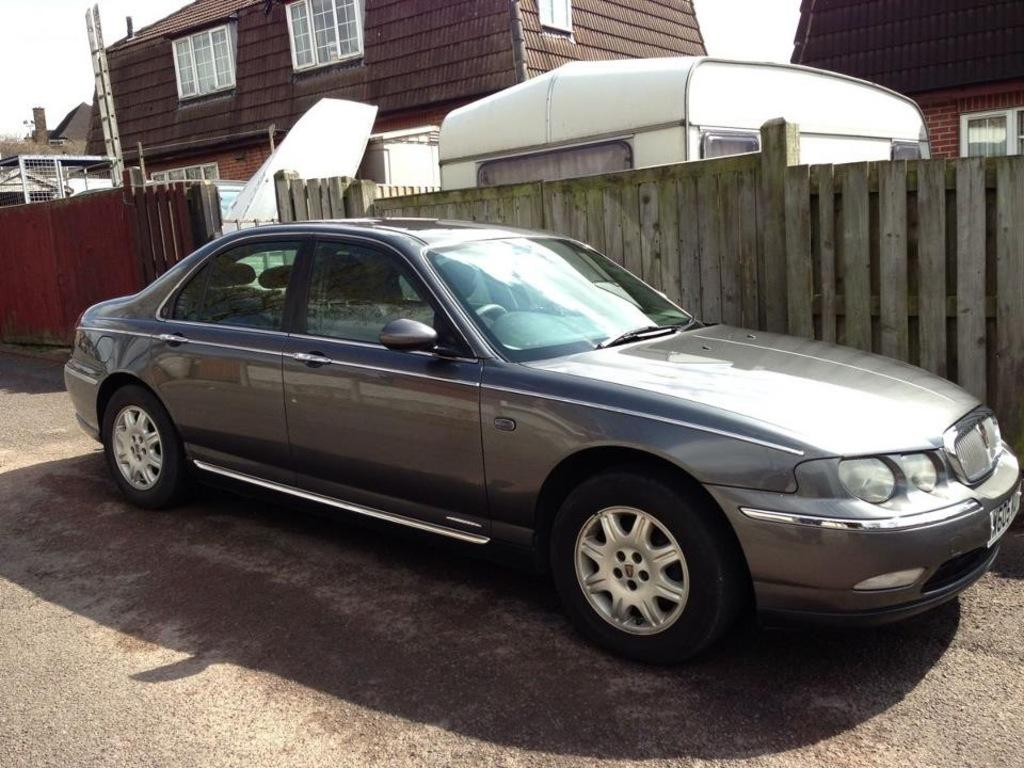What is the main subject of the image? The main subject of the image is a car. What type of fencing can be seen in the image? There is wooden fencing in the image. What other object is present in the image? There is a ladder in the image. What can be seen in the background of the image? There are buildings visible in the background of the image. What type of action is the father performing with the plane in the image? There is no father or plane present in the image; it features a car, wooden fencing, a ladder, and buildings in the background. 